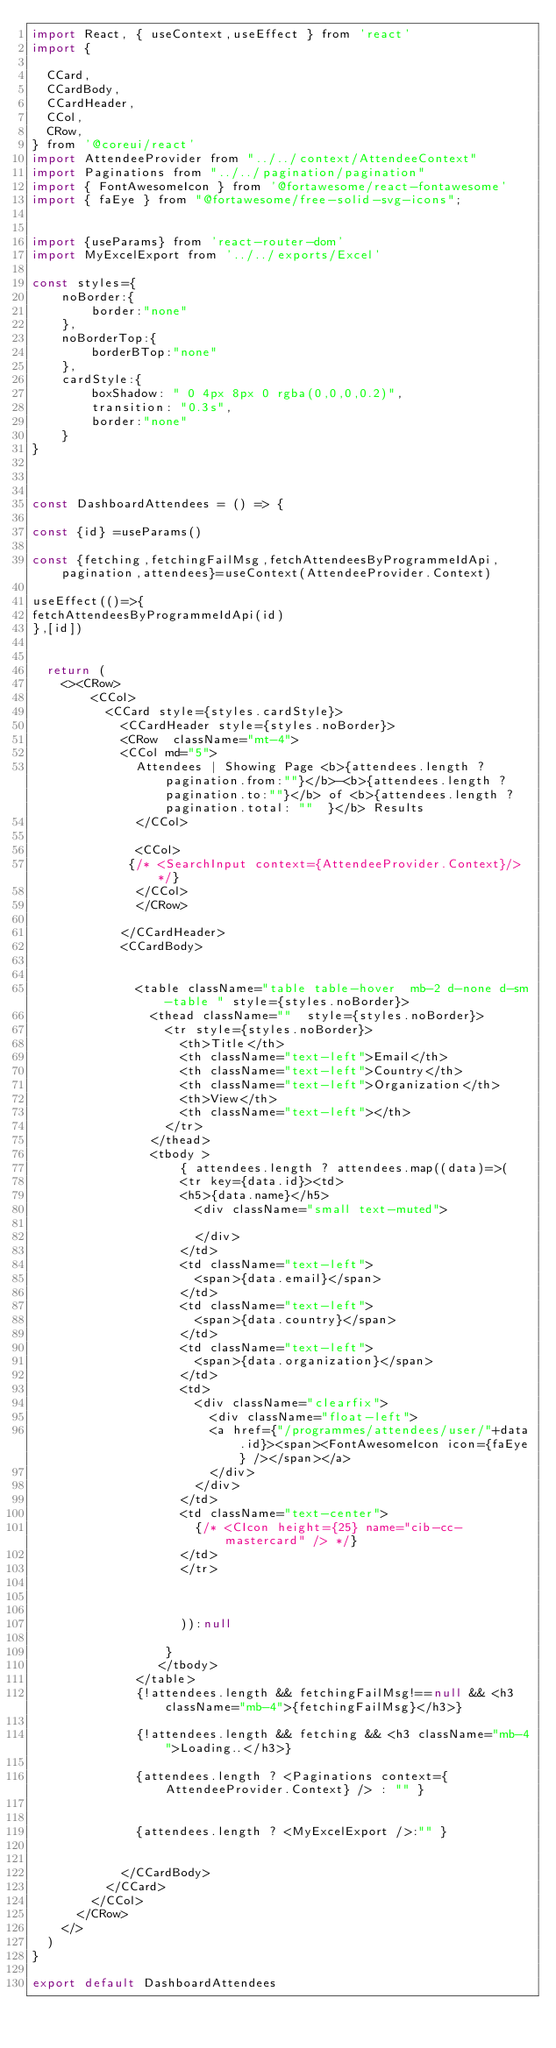<code> <loc_0><loc_0><loc_500><loc_500><_JavaScript_>import React, { useContext,useEffect } from 'react'
import {
 
  CCard,
  CCardBody,
  CCardHeader,
  CCol,
  CRow,
} from '@coreui/react'
import AttendeeProvider from "../../context/AttendeeContext"
import Paginations from "../../pagination/pagination"
import { FontAwesomeIcon } from '@fortawesome/react-fontawesome'
import { faEye } from "@fortawesome/free-solid-svg-icons";


import {useParams} from 'react-router-dom'
import MyExcelExport from '../../exports/Excel'

const styles={
    noBorder:{
        border:"none"
    },
    noBorderTop:{
        borderBTop:"none"
    },
    cardStyle:{
        boxShadow: " 0 4px 8px 0 rgba(0,0,0,0.2)",
        transition: "0.3s",
        border:"none"
    }
}



const DashboardAttendees = () => {

const {id} =useParams()

const {fetching,fetchingFailMsg,fetchAttendeesByProgrammeIdApi,pagination,attendees}=useContext(AttendeeProvider.Context)

useEffect(()=>{
fetchAttendeesByProgrammeIdApi(id)
},[id])


  return (
    <><CRow>
        <CCol>
          <CCard style={styles.cardStyle}>
            <CCardHeader style={styles.noBorder}>
            <CRow  className="mt-4">
            <CCol md="5">
              Attendees | Showing Page <b>{attendees.length ? pagination.from:""}</b>-<b>{attendees.length ? pagination.to:""}</b> of <b>{attendees.length ? pagination.total: ""  }</b> Results
              </CCol>

              <CCol>
             {/* <SearchInput context={AttendeeProvider.Context}/> */}
              </CCol>
              </CRow>
             
            </CCardHeader>
            <CCardBody>


              <table className="table table-hover  mb-2 d-none d-sm-table " style={styles.noBorder}>
                <thead className=""  style={styles.noBorder}>
                  <tr style={styles.noBorder}> 
                    <th>Title</th>
                    <th className="text-left">Email</th>
                    <th className="text-left">Country</th>
                    <th className="text-left">Organization</th>
                    <th>View</th>
                    <th className="text-left"></th>
                  </tr>
                </thead>
                <tbody >
                    { attendees.length ? attendees.map((data)=>( 
                    <tr key={data.id}><td>
                    <h5>{data.name}</h5>
                      <div className="small text-muted">
                        
                      </div>
                    </td>
                    <td className="text-left">
                      <span>{data.email}</span>
                    </td>
                    <td className="text-left">
                      <span>{data.country}</span>
                    </td>
                    <td className="text-left">
                      <span>{data.organization}</span>
                    </td>
                    <td>
                      <div className="clearfix">
                        <div className="float-left">
                        <a href={"/programmes/attendees/user/"+data.id}><span><FontAwesomeIcon icon={faEye} /></span></a>
                        </div>
                      </div> 
                    </td>
                    <td className="text-center">
                      {/* <CIcon height={25} name="cib-cc-mastercard" /> */}
                    </td>
                    </tr>


                   
                    )):null
                      
                  }
                 </tbody>
              </table>
              {!attendees.length && fetchingFailMsg!==null && <h3 className="mb-4">{fetchingFailMsg}</h3>}

              {!attendees.length && fetching && <h3 className="mb-4">Loading..</h3>}
              
              {attendees.length ? <Paginations context={AttendeeProvider.Context} /> : "" }
              
                 
              {attendees.length ? <MyExcelExport />:"" }
                

            </CCardBody>
          </CCard>
        </CCol>
      </CRow>
    </>
  )
}

export default DashboardAttendees
</code> 